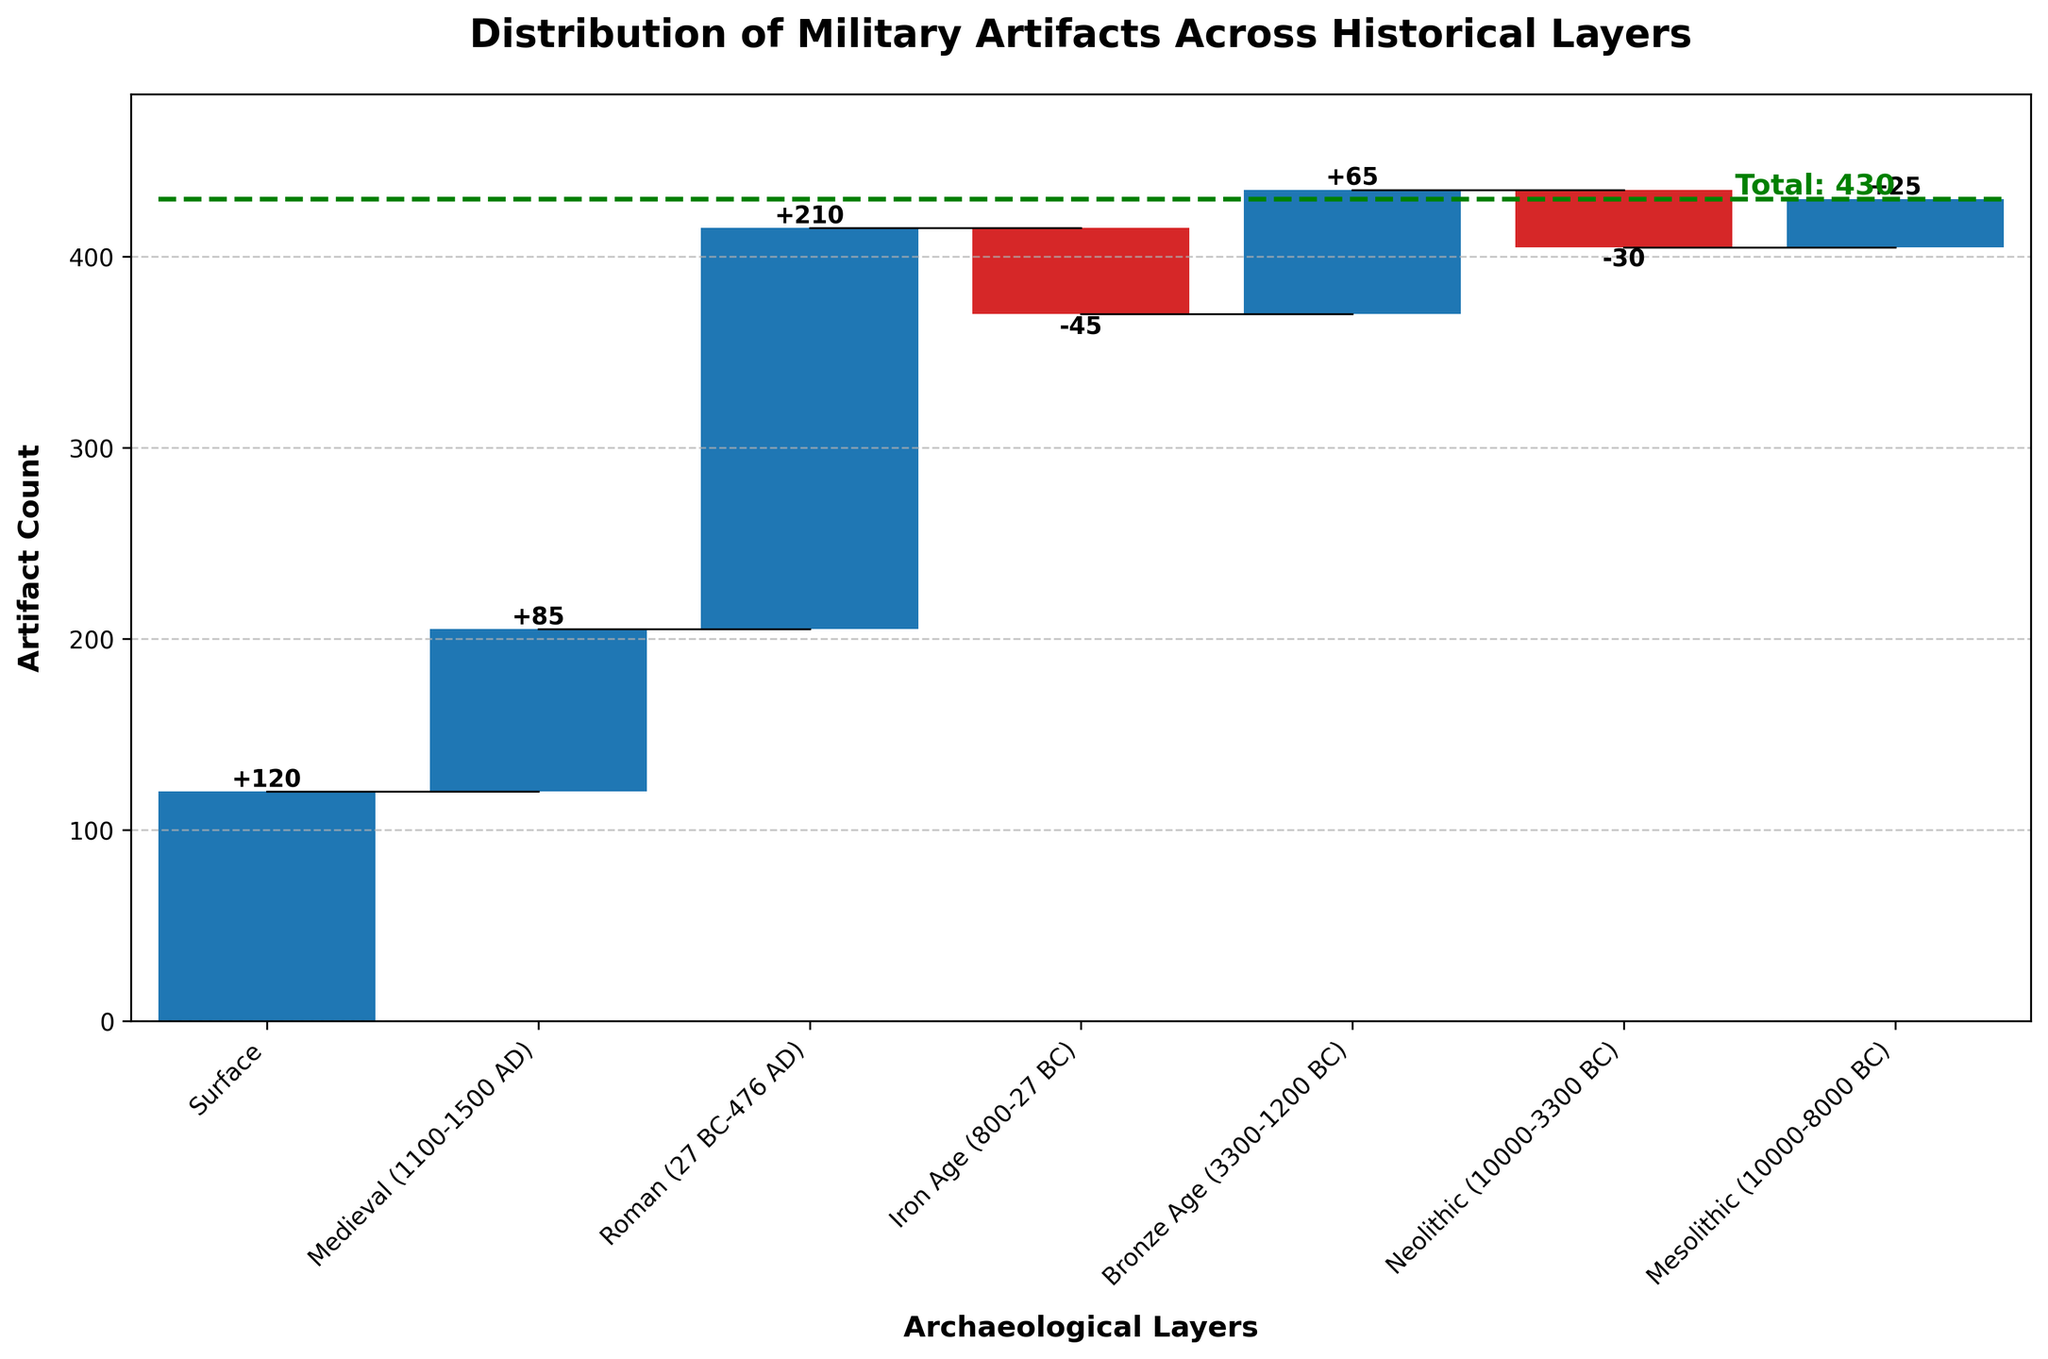What's the total number of artifacts found across all layers? The total number of artifacts is indicated by the green dashed line labeled "Total: 430" at the top right of the waterfall chart.
Answer: 430 Which layer has the highest count of military artifacts? The Roman layer has the highest bar, indicating 210 artifacts, which is the highest count among all layers.
Answer: Roman Which layers have a negative count of military artifacts? The Iron Age and Neolithic layers have red bars, which represent negative artifact counts. The Iron Age has -45 artifacts, and the Neolithic has -30 artifacts.
Answer: Iron Age and Neolithic What's the cumulative count after the Medieval layer? The cumulative count starts from the surface and reaches the Medieval layer. Adding 120 (Surface) and 85 (Medieval) gives 120 + 85 = 205.
Answer: 205 How does the artifact count change from the Roman layer to the Iron Age? The artifact count decreases from 210 (Roman) to -45 (Iron Age). The difference is 210 - (-45) = 255.
Answer: -255 What's the total artifact count before reaching the Bronze Age layer? Summing up the artifact counts from Surface to Iron Age: 120 (Surface) + 85 (Medieval) + 210 (Roman) - 45 (Iron Age) = 370.
Answer: 370 Which layer shows the smallest positive count? The Mesolithic layer has the smallest positive count with 25 artifacts.
Answer: Mesolithic Compare the artifact counts between the Surface and Bronze Age layers. Which one has more artifacts? The Surface layer has 120 artifacts, while the Bronze Age layer has 65 artifacts. The Surface layer has more artifacts than the Bronze Age layer.
Answer: Surface What is the artifact count difference between the Neolithic and Mesolithic layers? The Neolithic layer has -30 artifacts, and the Mesolithic has 25 artifacts. The difference is 25 - (-30) = 55.
Answer: 55 How is the artifact count trend as we go deeper from the Surface layer to the Mesolithic layer? The artifact count initially increases from Surface (120) to Roman (210), then decreases significantly through Iron Age (-45) and Neolithic (-30), before slightly increasing again in Mesolithic (25).
Answer: Increase-Decrease-Increase 